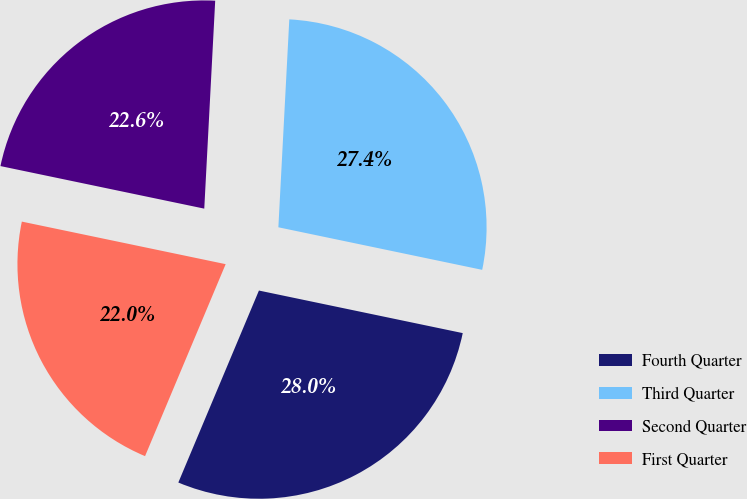Convert chart. <chart><loc_0><loc_0><loc_500><loc_500><pie_chart><fcel>Fourth Quarter<fcel>Third Quarter<fcel>Second Quarter<fcel>First Quarter<nl><fcel>28.05%<fcel>27.44%<fcel>22.56%<fcel>21.95%<nl></chart> 